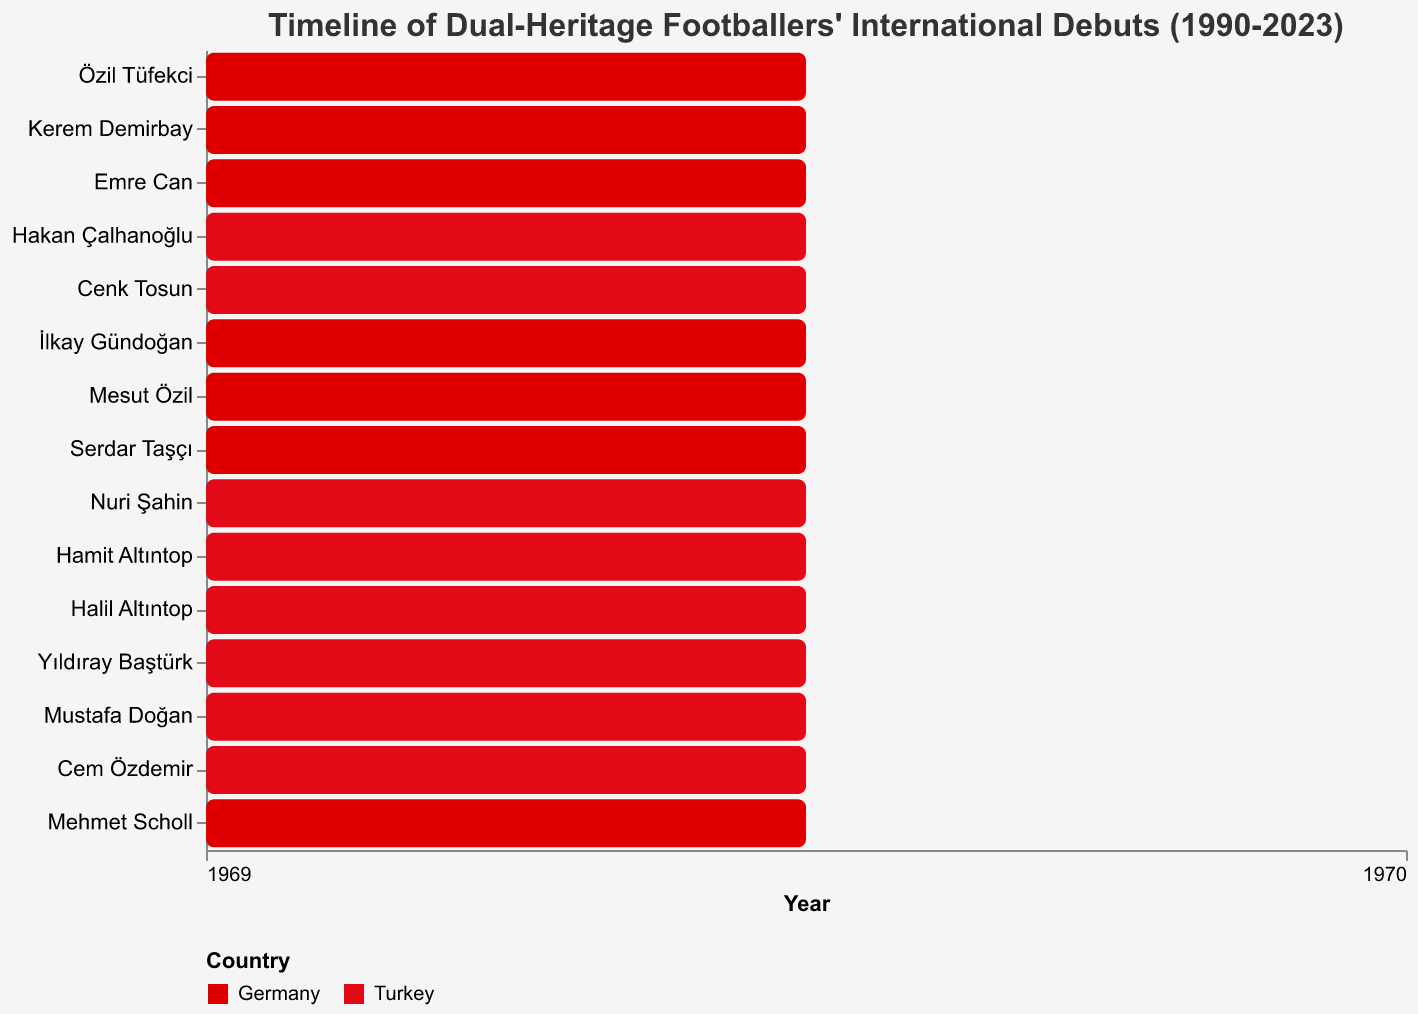What's the title of the figure? The title is located at the top of the figure and provides an overview. Reading it directly, it shows: "Timeline of Dual-Heritage Footballers' International Debuts (1990-2023)"
Answer: Timeline of Dual-Heritage Footballers' International Debuts (1990-2023) Which footballer had the longest international career? By comparing the difference between the "Start" and "End" years for each player, İlkay Gündoğan had the longest duration from 2011 to 2023, which is 12 years.
Answer: İlkay Gündoğan What are the two color codes used in the figure? Observing the bar colors, there are two distinct colors representing the countries. The dark red color represents Germany and the bright red color represents Turkey.
Answer: Dark red for Germany and bright red for Turkey How many footballers represented Turkey? Counting the bars colored in bright red, there are a total of 9 players representing Turkey.
Answer: 9 Which player had an international debut in 2015 and for which country? By looking at the "Start" axis and color-coded bars, we find Emre Can debuted in 2015 for Germany.
Answer: Emre Can, Germany How many players represented Germany after 2010? Counting Germany-colored bars (dark red) with start years after 2010, we see 5 players: Mesut Özil, İlkay Gündoğan, Emre Can, Kerem Demirbay, and Özil Tüfekci.
Answer: 5 Which country had more players with a career ending in or after 2020? By examining the "End" years and comparing the respective countries, both countries had 4 players each who ended careers in or after 2020.
Answer: Both countries had 4 How does the duration of Mesut Özil’s career compare to Yıldıray Baştürk's career? Mesut Özil's career spanned 9 years (2009–2018) whereas Yıldıray Baştürk's career spanned 9 years (1998–2007), making both careers of equal duration.
Answer: Both 9 years Which player had the shortest international career and for which country? Observing the length of the bars and using the tooltip for detail, Kerem Demirbay had the shortest career (2017-2019) for Germany.
Answer: Kerem Demirbay, Germany How many players had overlapping international careers between 2005 and 2014? Analyzing the overlapping bars within 2005 to 2014, there are four players: Hamit Altıntop, Nuri Şahin, Mesut Özil, and Halil Altıntop.
Answer: 4 